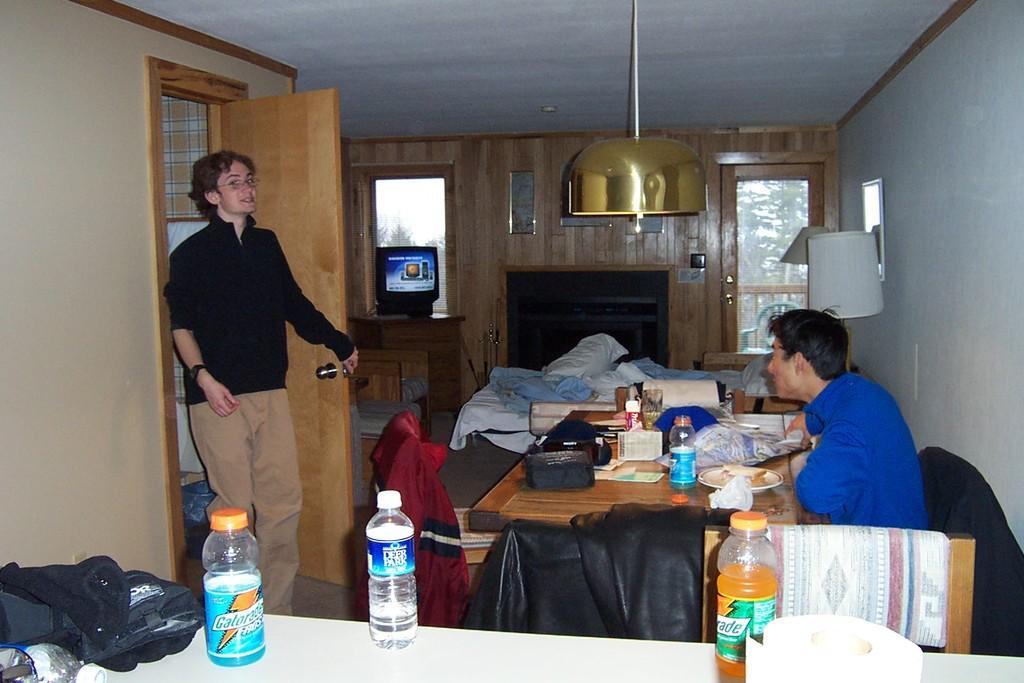Please provide a concise description of this image. In this picture a guy is sitting on the table on which food items are placed , to the left side of the image a guy is entering into the room. In the background there are wooden doors and a glass door. 